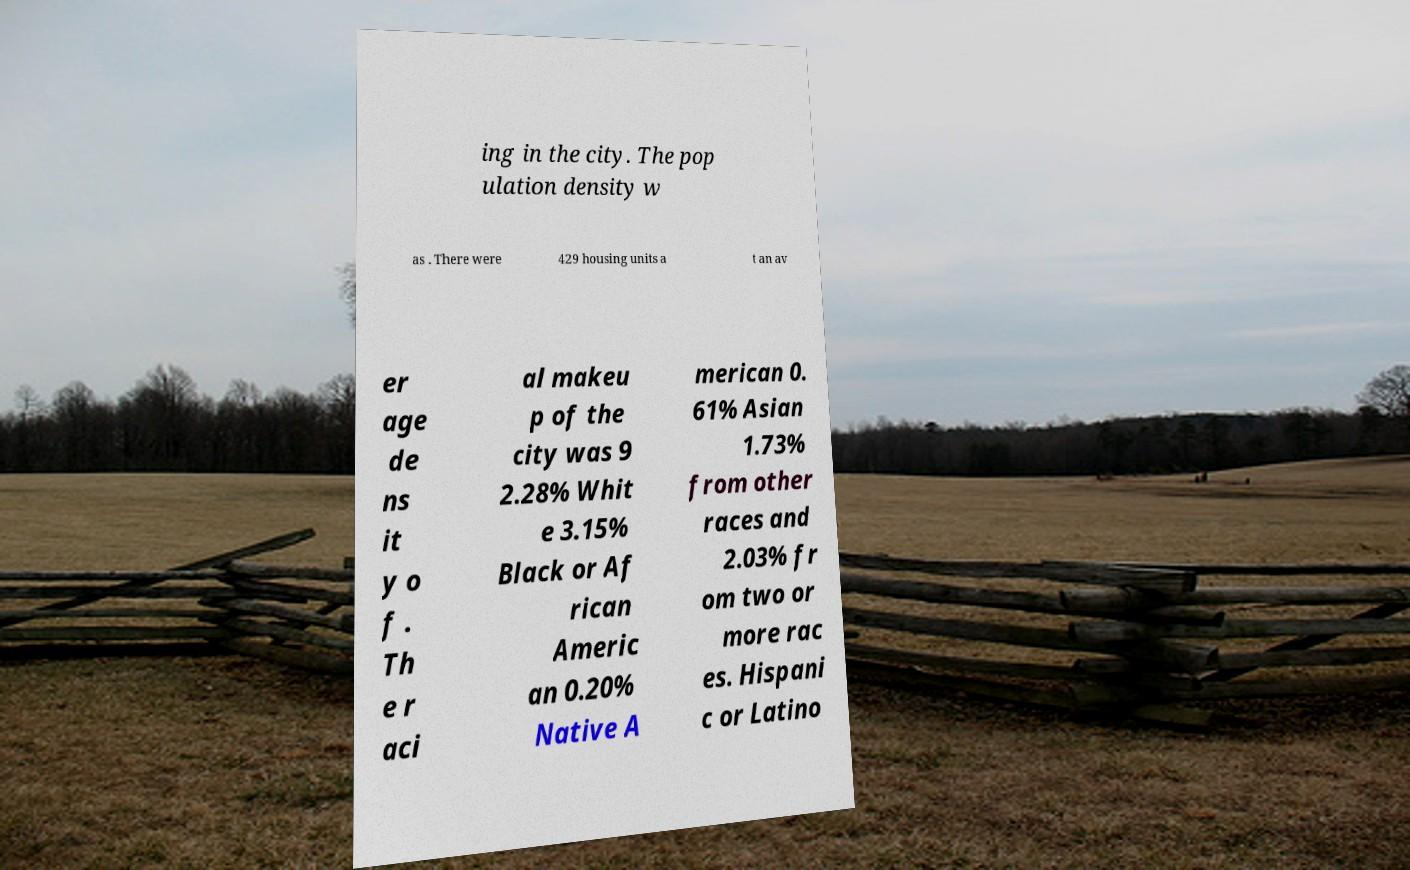There's text embedded in this image that I need extracted. Can you transcribe it verbatim? ing in the city. The pop ulation density w as . There were 429 housing units a t an av er age de ns it y o f . Th e r aci al makeu p of the city was 9 2.28% Whit e 3.15% Black or Af rican Americ an 0.20% Native A merican 0. 61% Asian 1.73% from other races and 2.03% fr om two or more rac es. Hispani c or Latino 